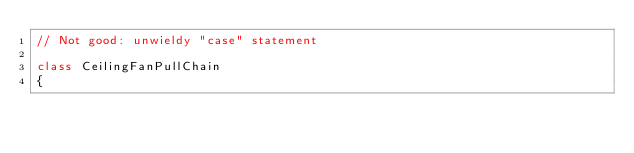<code> <loc_0><loc_0><loc_500><loc_500><_Java_>// Not good: unwieldy "case" statement

class CeilingFanPullChain
{</code> 